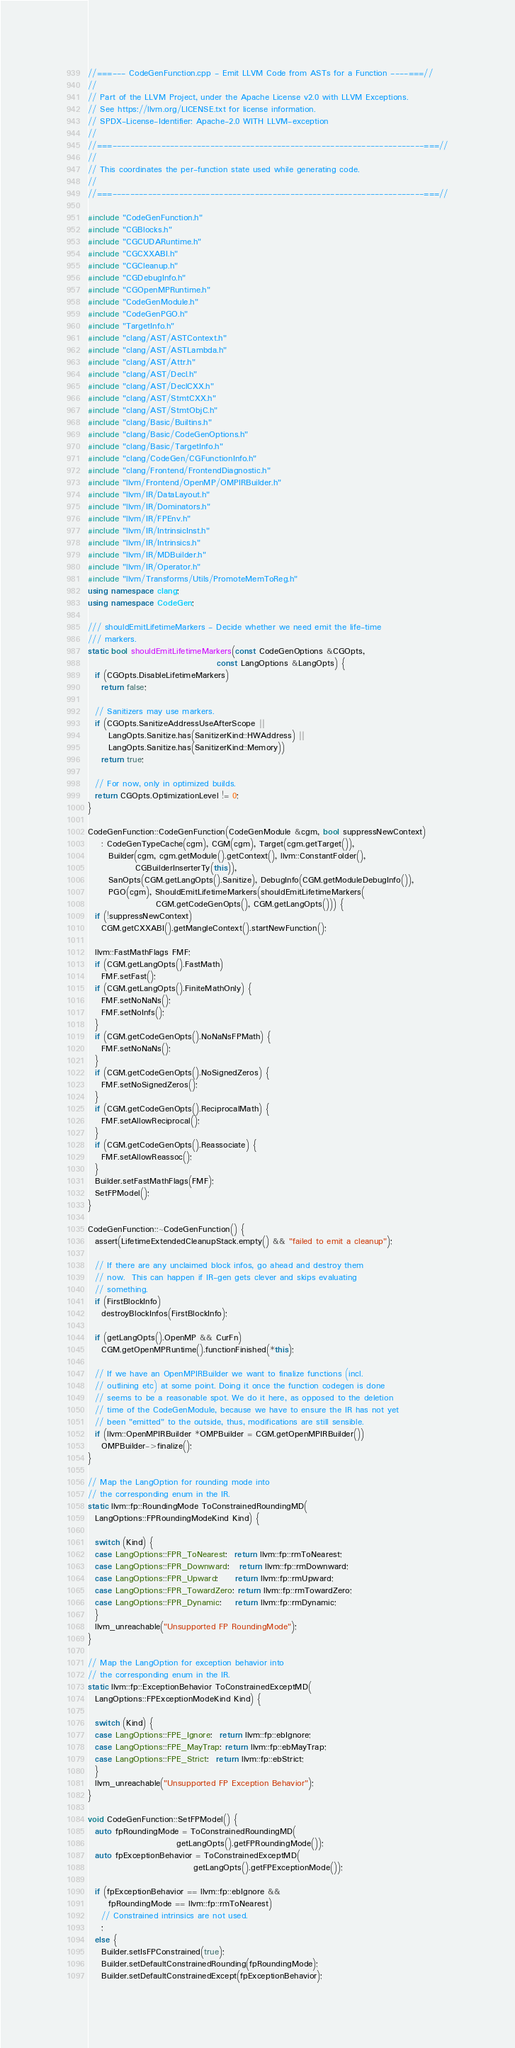Convert code to text. <code><loc_0><loc_0><loc_500><loc_500><_C++_>//===--- CodeGenFunction.cpp - Emit LLVM Code from ASTs for a Function ----===//
//
// Part of the LLVM Project, under the Apache License v2.0 with LLVM Exceptions.
// See https://llvm.org/LICENSE.txt for license information.
// SPDX-License-Identifier: Apache-2.0 WITH LLVM-exception
//
//===----------------------------------------------------------------------===//
//
// This coordinates the per-function state used while generating code.
//
//===----------------------------------------------------------------------===//

#include "CodeGenFunction.h"
#include "CGBlocks.h"
#include "CGCUDARuntime.h"
#include "CGCXXABI.h"
#include "CGCleanup.h"
#include "CGDebugInfo.h"
#include "CGOpenMPRuntime.h"
#include "CodeGenModule.h"
#include "CodeGenPGO.h"
#include "TargetInfo.h"
#include "clang/AST/ASTContext.h"
#include "clang/AST/ASTLambda.h"
#include "clang/AST/Attr.h"
#include "clang/AST/Decl.h"
#include "clang/AST/DeclCXX.h"
#include "clang/AST/StmtCXX.h"
#include "clang/AST/StmtObjC.h"
#include "clang/Basic/Builtins.h"
#include "clang/Basic/CodeGenOptions.h"
#include "clang/Basic/TargetInfo.h"
#include "clang/CodeGen/CGFunctionInfo.h"
#include "clang/Frontend/FrontendDiagnostic.h"
#include "llvm/Frontend/OpenMP/OMPIRBuilder.h"
#include "llvm/IR/DataLayout.h"
#include "llvm/IR/Dominators.h"
#include "llvm/IR/FPEnv.h"
#include "llvm/IR/IntrinsicInst.h"
#include "llvm/IR/Intrinsics.h"
#include "llvm/IR/MDBuilder.h"
#include "llvm/IR/Operator.h"
#include "llvm/Transforms/Utils/PromoteMemToReg.h"
using namespace clang;
using namespace CodeGen;

/// shouldEmitLifetimeMarkers - Decide whether we need emit the life-time
/// markers.
static bool shouldEmitLifetimeMarkers(const CodeGenOptions &CGOpts,
                                      const LangOptions &LangOpts) {
  if (CGOpts.DisableLifetimeMarkers)
    return false;

  // Sanitizers may use markers.
  if (CGOpts.SanitizeAddressUseAfterScope ||
      LangOpts.Sanitize.has(SanitizerKind::HWAddress) ||
      LangOpts.Sanitize.has(SanitizerKind::Memory))
    return true;

  // For now, only in optimized builds.
  return CGOpts.OptimizationLevel != 0;
}

CodeGenFunction::CodeGenFunction(CodeGenModule &cgm, bool suppressNewContext)
    : CodeGenTypeCache(cgm), CGM(cgm), Target(cgm.getTarget()),
      Builder(cgm, cgm.getModule().getContext(), llvm::ConstantFolder(),
              CGBuilderInserterTy(this)),
      SanOpts(CGM.getLangOpts().Sanitize), DebugInfo(CGM.getModuleDebugInfo()),
      PGO(cgm), ShouldEmitLifetimeMarkers(shouldEmitLifetimeMarkers(
                    CGM.getCodeGenOpts(), CGM.getLangOpts())) {
  if (!suppressNewContext)
    CGM.getCXXABI().getMangleContext().startNewFunction();

  llvm::FastMathFlags FMF;
  if (CGM.getLangOpts().FastMath)
    FMF.setFast();
  if (CGM.getLangOpts().FiniteMathOnly) {
    FMF.setNoNaNs();
    FMF.setNoInfs();
  }
  if (CGM.getCodeGenOpts().NoNaNsFPMath) {
    FMF.setNoNaNs();
  }
  if (CGM.getCodeGenOpts().NoSignedZeros) {
    FMF.setNoSignedZeros();
  }
  if (CGM.getCodeGenOpts().ReciprocalMath) {
    FMF.setAllowReciprocal();
  }
  if (CGM.getCodeGenOpts().Reassociate) {
    FMF.setAllowReassoc();
  }
  Builder.setFastMathFlags(FMF);
  SetFPModel();
}

CodeGenFunction::~CodeGenFunction() {
  assert(LifetimeExtendedCleanupStack.empty() && "failed to emit a cleanup");

  // If there are any unclaimed block infos, go ahead and destroy them
  // now.  This can happen if IR-gen gets clever and skips evaluating
  // something.
  if (FirstBlockInfo)
    destroyBlockInfos(FirstBlockInfo);

  if (getLangOpts().OpenMP && CurFn)
    CGM.getOpenMPRuntime().functionFinished(*this);

  // If we have an OpenMPIRBuilder we want to finalize functions (incl.
  // outlining etc) at some point. Doing it once the function codegen is done
  // seems to be a reasonable spot. We do it here, as opposed to the deletion
  // time of the CodeGenModule, because we have to ensure the IR has not yet
  // been "emitted" to the outside, thus, modifications are still sensible.
  if (llvm::OpenMPIRBuilder *OMPBuilder = CGM.getOpenMPIRBuilder())
    OMPBuilder->finalize();
}

// Map the LangOption for rounding mode into
// the corresponding enum in the IR.
static llvm::fp::RoundingMode ToConstrainedRoundingMD(
  LangOptions::FPRoundingModeKind Kind) {

  switch (Kind) {
  case LangOptions::FPR_ToNearest:  return llvm::fp::rmToNearest;
  case LangOptions::FPR_Downward:   return llvm::fp::rmDownward;
  case LangOptions::FPR_Upward:     return llvm::fp::rmUpward;
  case LangOptions::FPR_TowardZero: return llvm::fp::rmTowardZero;
  case LangOptions::FPR_Dynamic:    return llvm::fp::rmDynamic;
  }
  llvm_unreachable("Unsupported FP RoundingMode");
}

// Map the LangOption for exception behavior into
// the corresponding enum in the IR.
static llvm::fp::ExceptionBehavior ToConstrainedExceptMD(
  LangOptions::FPExceptionModeKind Kind) {

  switch (Kind) {
  case LangOptions::FPE_Ignore:  return llvm::fp::ebIgnore;
  case LangOptions::FPE_MayTrap: return llvm::fp::ebMayTrap;
  case LangOptions::FPE_Strict:  return llvm::fp::ebStrict;
  }
  llvm_unreachable("Unsupported FP Exception Behavior");
}

void CodeGenFunction::SetFPModel() {
  auto fpRoundingMode = ToConstrainedRoundingMD(
                          getLangOpts().getFPRoundingMode());
  auto fpExceptionBehavior = ToConstrainedExceptMD(
                               getLangOpts().getFPExceptionMode());

  if (fpExceptionBehavior == llvm::fp::ebIgnore &&
      fpRoundingMode == llvm::fp::rmToNearest)
    // Constrained intrinsics are not used.
    ;
  else {
    Builder.setIsFPConstrained(true);
    Builder.setDefaultConstrainedRounding(fpRoundingMode);
    Builder.setDefaultConstrainedExcept(fpExceptionBehavior);</code> 